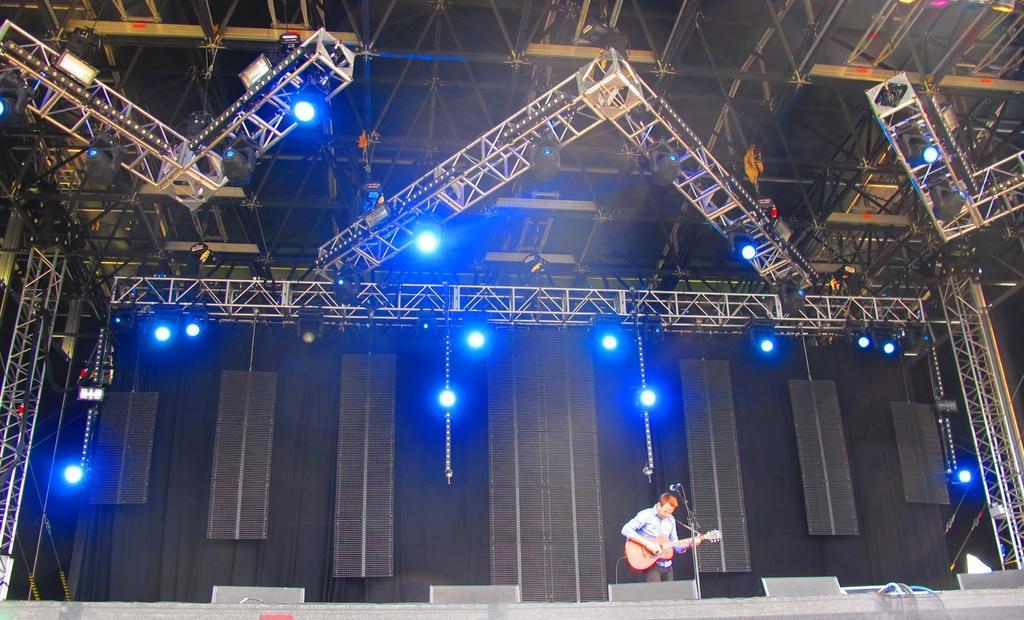Could you give a brief overview of what you see in this image? In the picture we can find a man holding guitar in a front of microphone and in the background we can find many lights and stands to the ceiling. 